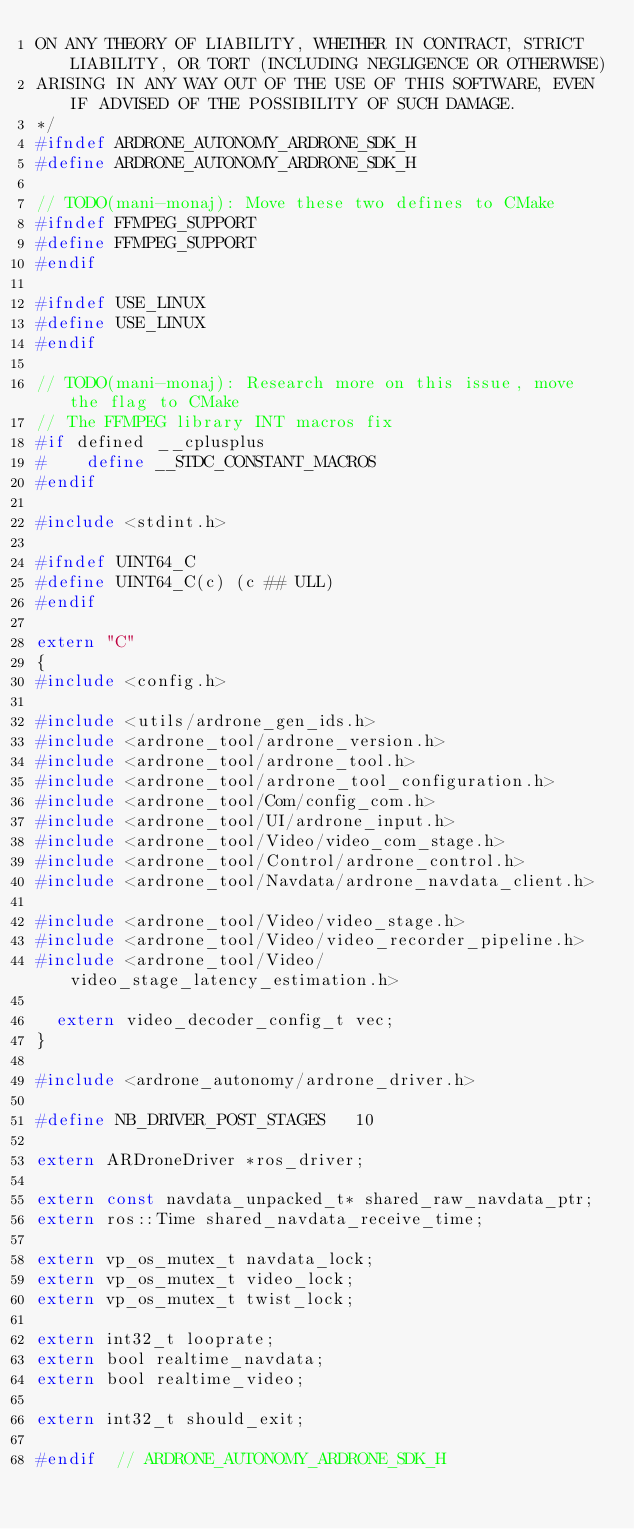<code> <loc_0><loc_0><loc_500><loc_500><_C_>ON ANY THEORY OF LIABILITY, WHETHER IN CONTRACT, STRICT LIABILITY, OR TORT (INCLUDING NEGLIGENCE OR OTHERWISE)
ARISING IN ANY WAY OUT OF THE USE OF THIS SOFTWARE, EVEN IF ADVISED OF THE POSSIBILITY OF SUCH DAMAGE.
*/
#ifndef ARDRONE_AUTONOMY_ARDRONE_SDK_H
#define ARDRONE_AUTONOMY_ARDRONE_SDK_H

// TODO(mani-monaj): Move these two defines to CMake
#ifndef FFMPEG_SUPPORT
#define FFMPEG_SUPPORT
#endif

#ifndef USE_LINUX
#define USE_LINUX
#endif

// TODO(mani-monaj): Research more on this issue, move the flag to CMake
// The FFMPEG library INT macros fix
#if defined __cplusplus
#    define __STDC_CONSTANT_MACROS
#endif

#include <stdint.h>

#ifndef UINT64_C
#define UINT64_C(c) (c ## ULL)
#endif

extern "C"
{
#include <config.h>

#include <utils/ardrone_gen_ids.h>
#include <ardrone_tool/ardrone_version.h>
#include <ardrone_tool/ardrone_tool.h>
#include <ardrone_tool/ardrone_tool_configuration.h>
#include <ardrone_tool/Com/config_com.h>
#include <ardrone_tool/UI/ardrone_input.h>
#include <ardrone_tool/Video/video_com_stage.h>
#include <ardrone_tool/Control/ardrone_control.h>
#include <ardrone_tool/Navdata/ardrone_navdata_client.h>

#include <ardrone_tool/Video/video_stage.h>
#include <ardrone_tool/Video/video_recorder_pipeline.h>
#include <ardrone_tool/Video/video_stage_latency_estimation.h>

  extern video_decoder_config_t vec;
}

#include <ardrone_autonomy/ardrone_driver.h>

#define NB_DRIVER_POST_STAGES   10

extern ARDroneDriver *ros_driver;

extern const navdata_unpacked_t* shared_raw_navdata_ptr;
extern ros::Time shared_navdata_receive_time;

extern vp_os_mutex_t navdata_lock;
extern vp_os_mutex_t video_lock;
extern vp_os_mutex_t twist_lock;

extern int32_t looprate;
extern bool realtime_navdata;
extern bool realtime_video;

extern int32_t should_exit;

#endif  // ARDRONE_AUTONOMY_ARDRONE_SDK_H
</code> 